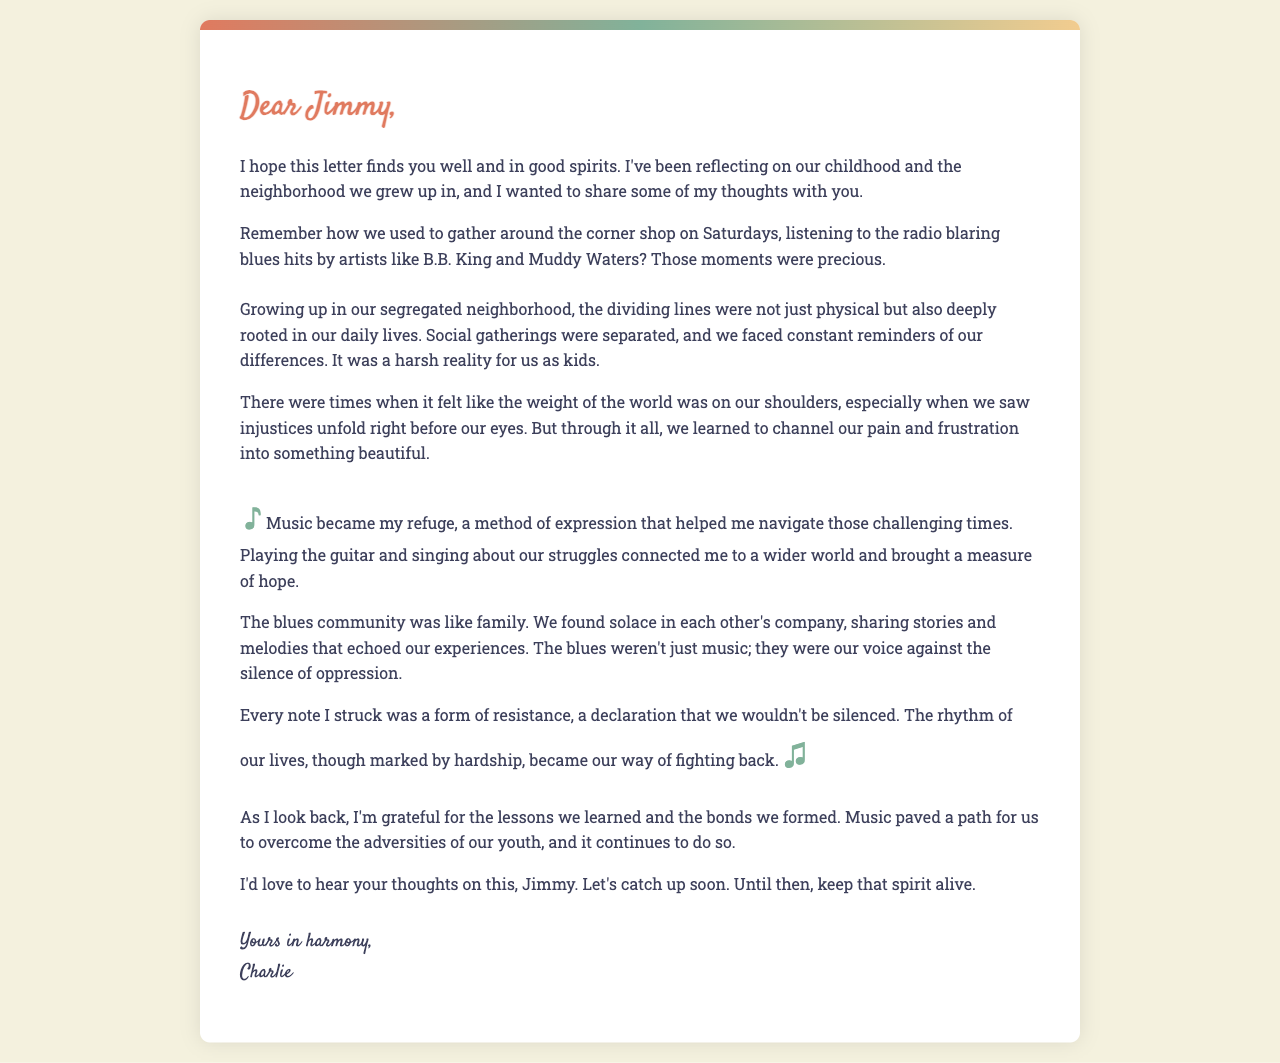What was the name of the friend Charlie addressed in the letter? The letter is specifically addressed to a childhood friend named Jimmy, indicating their close relationship and shared memories from their past.
Answer: Jimmy What musical genre does Charlie mention in the letter? Charlie reflects on the blues genre, including notable artists, and how it influenced his life growing up in a segregated neighborhood.
Answer: Blues What type of gatherings were affected by segregation? Segregation impacted social interactions and gatherings within the community, highlighting the division based on race that shaped their experiences.
Answer: Social gatherings Which artists were referenced in the letter? Charlie recalls listening to blues hits by specific artists, including B.B. King and Muddy Waters, emphasizing the influence of their music during childhood.
Answer: B.B. King and Muddy Waters What does music represent for Charlie in the letter? For Charlie, music symbolizes a refuge and a method of expression that allowed him to cope with the challenges and injustices he faced, serving as a form of resistance.
Answer: Refuge How did music contribute to Charlie's connections with others? Music fostered a sense of community among musicians and friends, allowing them to share stories and experiences that resonated with their struggles and hardships.
Answer: Connected them What does Charlie express gratitude for in the letter? Charlie expresses gratitude for the lessons learned and bonds formed during their youth, which music facilitated and helped them overcome adversity.
Answer: Lessons and bonds What does Charlie hope to do with Jimmy soon? Charlie wishes to reconnect and catch up with his childhood friend Jimmy, indicating a desire to share more about their lives and experiences.
Answer: Catch up 